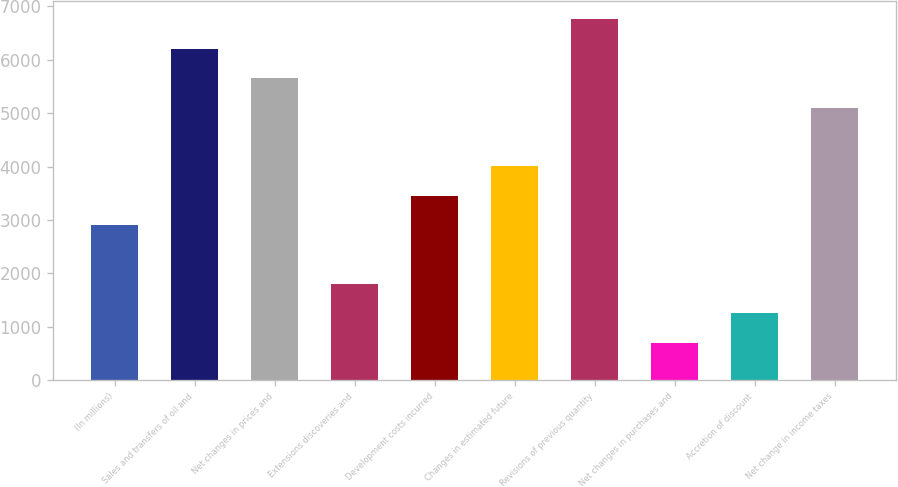Convert chart. <chart><loc_0><loc_0><loc_500><loc_500><bar_chart><fcel>(In millions)<fcel>Sales and transfers of oil and<fcel>Net changes in prices and<fcel>Extensions discoveries and<fcel>Development costs incurred<fcel>Changes in estimated future<fcel>Revisions of previous quantity<fcel>Net changes in purchases and<fcel>Accretion of discount<fcel>Net change in income taxes<nl><fcel>2902<fcel>6205.6<fcel>5655<fcel>1800.8<fcel>3452.6<fcel>4003.2<fcel>6756.2<fcel>699.6<fcel>1250.2<fcel>5104.4<nl></chart> 